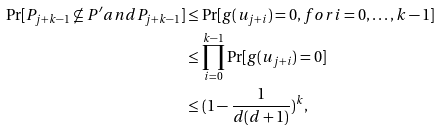<formula> <loc_0><loc_0><loc_500><loc_500>\Pr [ P _ { j + k - 1 } \not \subseteq P ^ { \prime } a n d P _ { j + k - 1 } ] & \leq \Pr [ g ( u _ { j + i } ) = 0 , f o r i = 0 , \dots , k - 1 ] \\ & \leq \prod _ { i = 0 } ^ { k - 1 } \Pr [ g ( u _ { j + i } ) = 0 ] \\ & \leq ( 1 - \frac { 1 } { d ( d + 1 ) } ) ^ { k } ,</formula> 